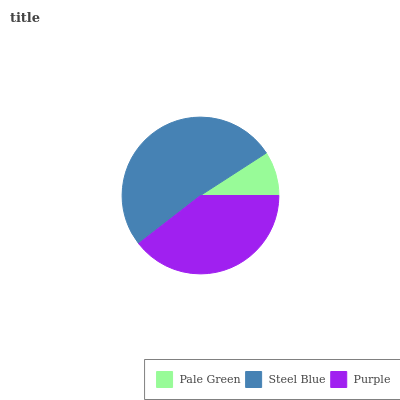Is Pale Green the minimum?
Answer yes or no. Yes. Is Steel Blue the maximum?
Answer yes or no. Yes. Is Purple the minimum?
Answer yes or no. No. Is Purple the maximum?
Answer yes or no. No. Is Steel Blue greater than Purple?
Answer yes or no. Yes. Is Purple less than Steel Blue?
Answer yes or no. Yes. Is Purple greater than Steel Blue?
Answer yes or no. No. Is Steel Blue less than Purple?
Answer yes or no. No. Is Purple the high median?
Answer yes or no. Yes. Is Purple the low median?
Answer yes or no. Yes. Is Steel Blue the high median?
Answer yes or no. No. Is Steel Blue the low median?
Answer yes or no. No. 